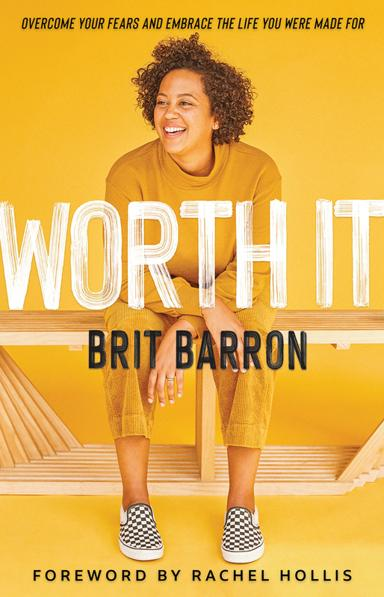What is the title of the book mentioned in the image? The title of the book shown in the image is "Worth It: Overcome Your Fears and Embrace the Life You Were Made For," authored by Brit Barron. The cover features a cheerful Brit Barron sitting against a vibrant yellow background, symbolizing the book's uplifting and empowering message. 